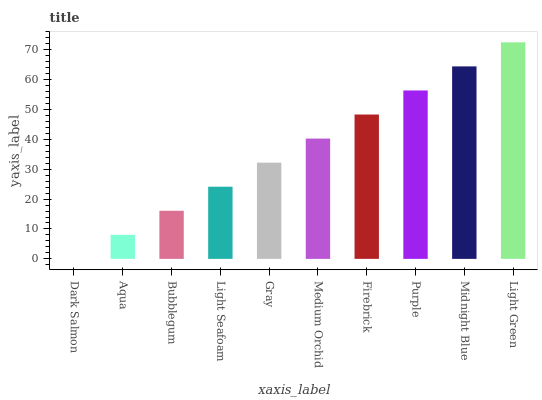Is Dark Salmon the minimum?
Answer yes or no. Yes. Is Light Green the maximum?
Answer yes or no. Yes. Is Aqua the minimum?
Answer yes or no. No. Is Aqua the maximum?
Answer yes or no. No. Is Aqua greater than Dark Salmon?
Answer yes or no. Yes. Is Dark Salmon less than Aqua?
Answer yes or no. Yes. Is Dark Salmon greater than Aqua?
Answer yes or no. No. Is Aqua less than Dark Salmon?
Answer yes or no. No. Is Medium Orchid the high median?
Answer yes or no. Yes. Is Gray the low median?
Answer yes or no. Yes. Is Aqua the high median?
Answer yes or no. No. Is Light Green the low median?
Answer yes or no. No. 